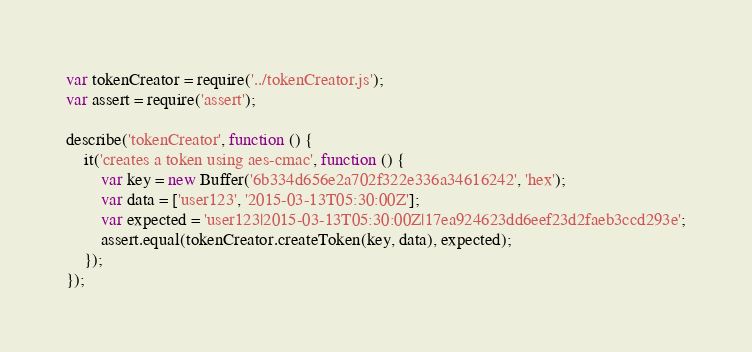Convert code to text. <code><loc_0><loc_0><loc_500><loc_500><_JavaScript_>var tokenCreator = require('../tokenCreator.js');
var assert = require('assert');

describe('tokenCreator', function () {
	it('creates a token using aes-cmac', function () {
		var key = new Buffer('6b334d656e2a702f322e336a34616242', 'hex');
		var data = ['user123', '2015-03-13T05:30:00Z'];
		var expected = 'user123|2015-03-13T05:30:00Z|17ea924623dd6eef23d2faeb3ccd293e';
		assert.equal(tokenCreator.createToken(key, data), expected);
	});
});
</code> 